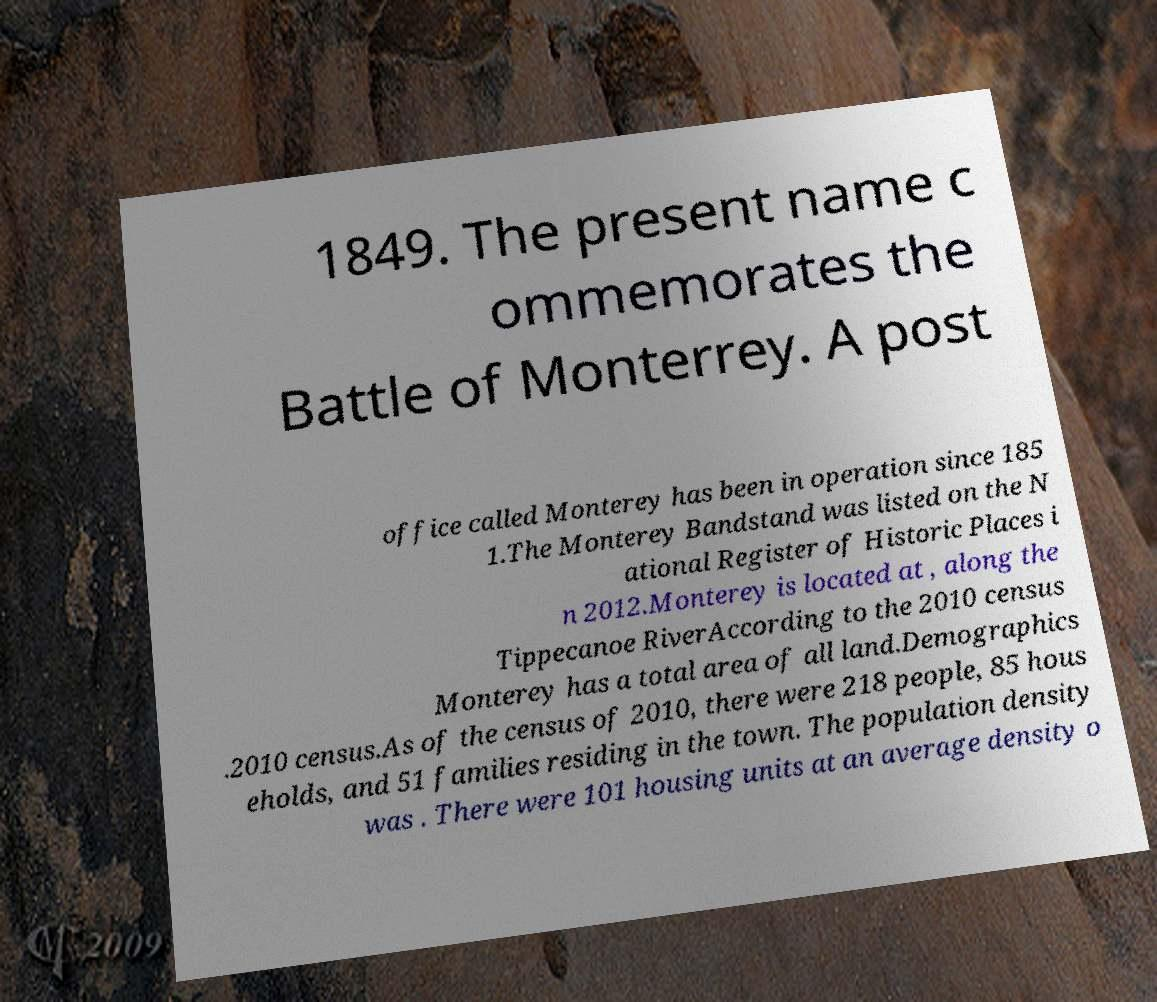There's text embedded in this image that I need extracted. Can you transcribe it verbatim? 1849. The present name c ommemorates the Battle of Monterrey. A post office called Monterey has been in operation since 185 1.The Monterey Bandstand was listed on the N ational Register of Historic Places i n 2012.Monterey is located at , along the Tippecanoe RiverAccording to the 2010 census Monterey has a total area of all land.Demographics .2010 census.As of the census of 2010, there were 218 people, 85 hous eholds, and 51 families residing in the town. The population density was . There were 101 housing units at an average density o 